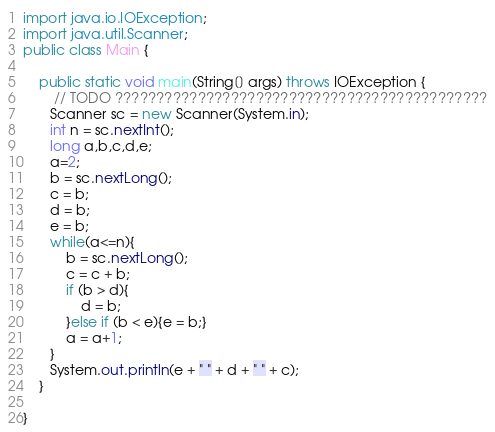Convert code to text. <code><loc_0><loc_0><loc_500><loc_500><_Java_>import java.io.IOException;
import java.util.Scanner;
public class Main {

	public static void main(String[] args) throws IOException {
		// TODO ?????????????????????????????????????????????
       Scanner sc = new Scanner(System.in);
       int n = sc.nextInt();
       long a,b,c,d,e;
       a=2;
       b = sc.nextLong();
       c = b;
       d = b;
       e = b;
       while(a<=n){
    	   b = sc.nextLong();
    	   c = c + b;
    	   if (b > d){
    		   d = b;
    	   }else if (b < e){e = b;}
    	   a = a+1;
       }
       System.out.println(e + " " + d + " " + c);
	}

}</code> 